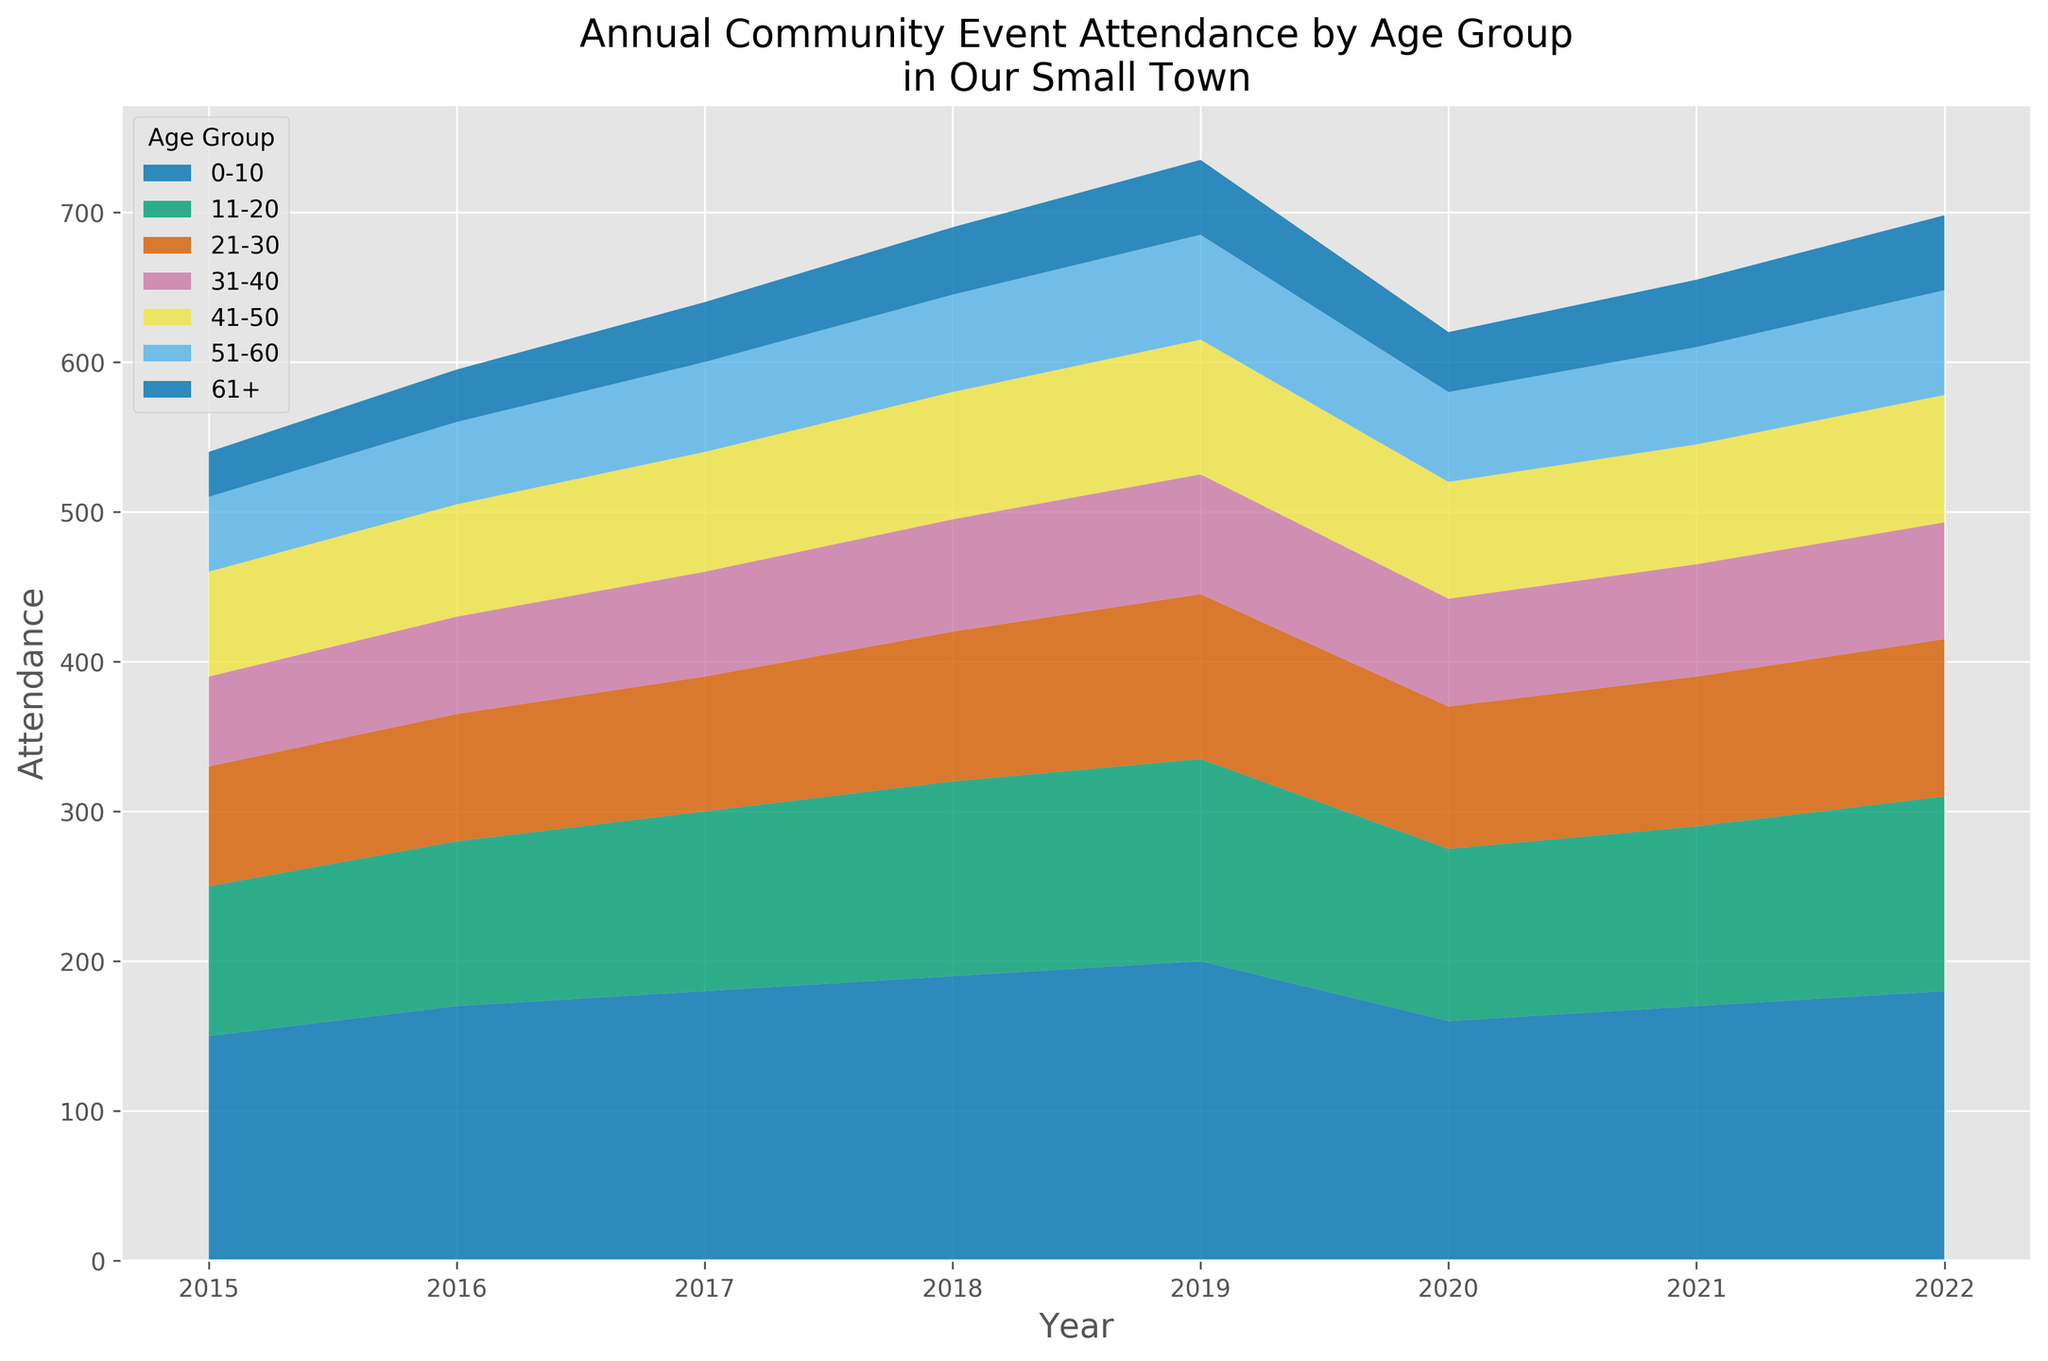What trend do you observe in the attendance of the 0-10 age group from 2015 to 2022? From 2015 to 2019, there is a general increase in attendance for the 0-10 age group, peaking at 200 in 2019. The attendance then drops to 160 in 2020 but starts increasing again in 2021 and 2022.
Answer: Increasing from 2015 to 2019, then drops in 2020, and gradually increases again Which age group had the highest attendance in 2019? By visually comparing the height of the colored areas representing each age group for the year 2019, it becomes evident that the 0-10 age group had the highest attendance.
Answer: 0-10 How did the attendance for the 51-60 age group change from 2019 to 2020? The attendance for the 51-60 age group was at 70 in 2019 and decreased to 60 in 2020.
Answer: Decreased by 10 What is the sum of attendance for the 21-30 and 31-40 age groups in 2022? In 2022, the attendance for the 21-30 age group was 105 and for the 31-40 age group, it was 78. Summing these up gives 105 + 78 = 183.
Answer: 183 Which age group had a consistently increasing attendance from 2015 to 2019? Observing the height of the colored areas for each age group from 2015 to 2019, the 0-10 age group shows a consistent increase in attendance year over year.
Answer: 0-10 Which year observed the lowest overall attendance across all age groups? By comparing the overall heights of the stacked areas for each year, 2015 appears as the year with the lowest overall attendance.
Answer: 2015 What's the combined attendance for the 61+ age group from 2017 to 2019? Attendance for the 61+ age group in 2017 was 40, in 2018 it was 45, and in 2019 it was 50. Summing these gives 40 + 45 + 50 = 135.
Answer: 135 How did the total attendance change from 2020 to 2021? Summing the attendance of all age groups for 2020 and 2021, we get 620 for 2020 and 655 for 2021. The total attendance increased by 655 - 620 = 35 from 2020 to 2021.
Answer: Increased by 35 